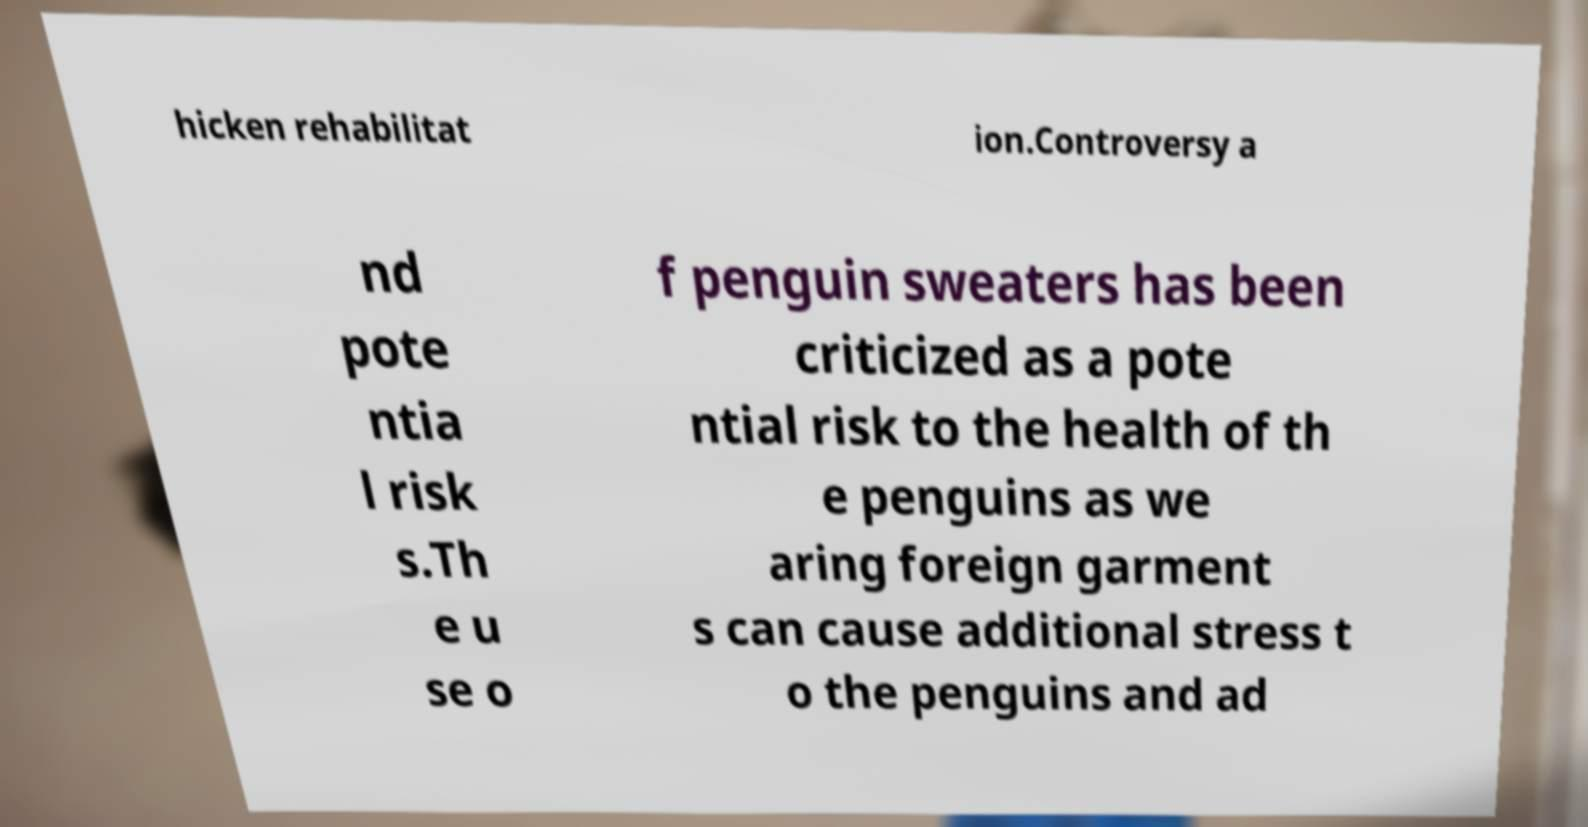Could you assist in decoding the text presented in this image and type it out clearly? hicken rehabilitat ion.Controversy a nd pote ntia l risk s.Th e u se o f penguin sweaters has been criticized as a pote ntial risk to the health of th e penguins as we aring foreign garment s can cause additional stress t o the penguins and ad 